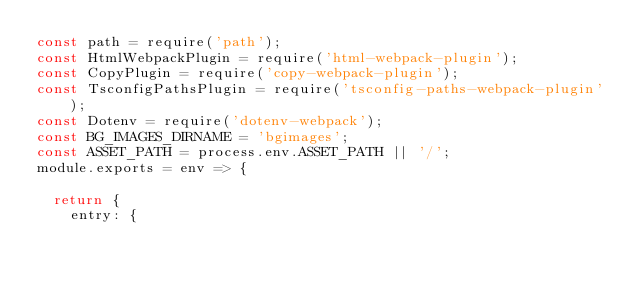Convert code to text. <code><loc_0><loc_0><loc_500><loc_500><_JavaScript_>const path = require('path');
const HtmlWebpackPlugin = require('html-webpack-plugin');
const CopyPlugin = require('copy-webpack-plugin');
const TsconfigPathsPlugin = require('tsconfig-paths-webpack-plugin');
const Dotenv = require('dotenv-webpack');
const BG_IMAGES_DIRNAME = 'bgimages';
const ASSET_PATH = process.env.ASSET_PATH || '/';
module.exports = env => {

  return {
    entry: {</code> 